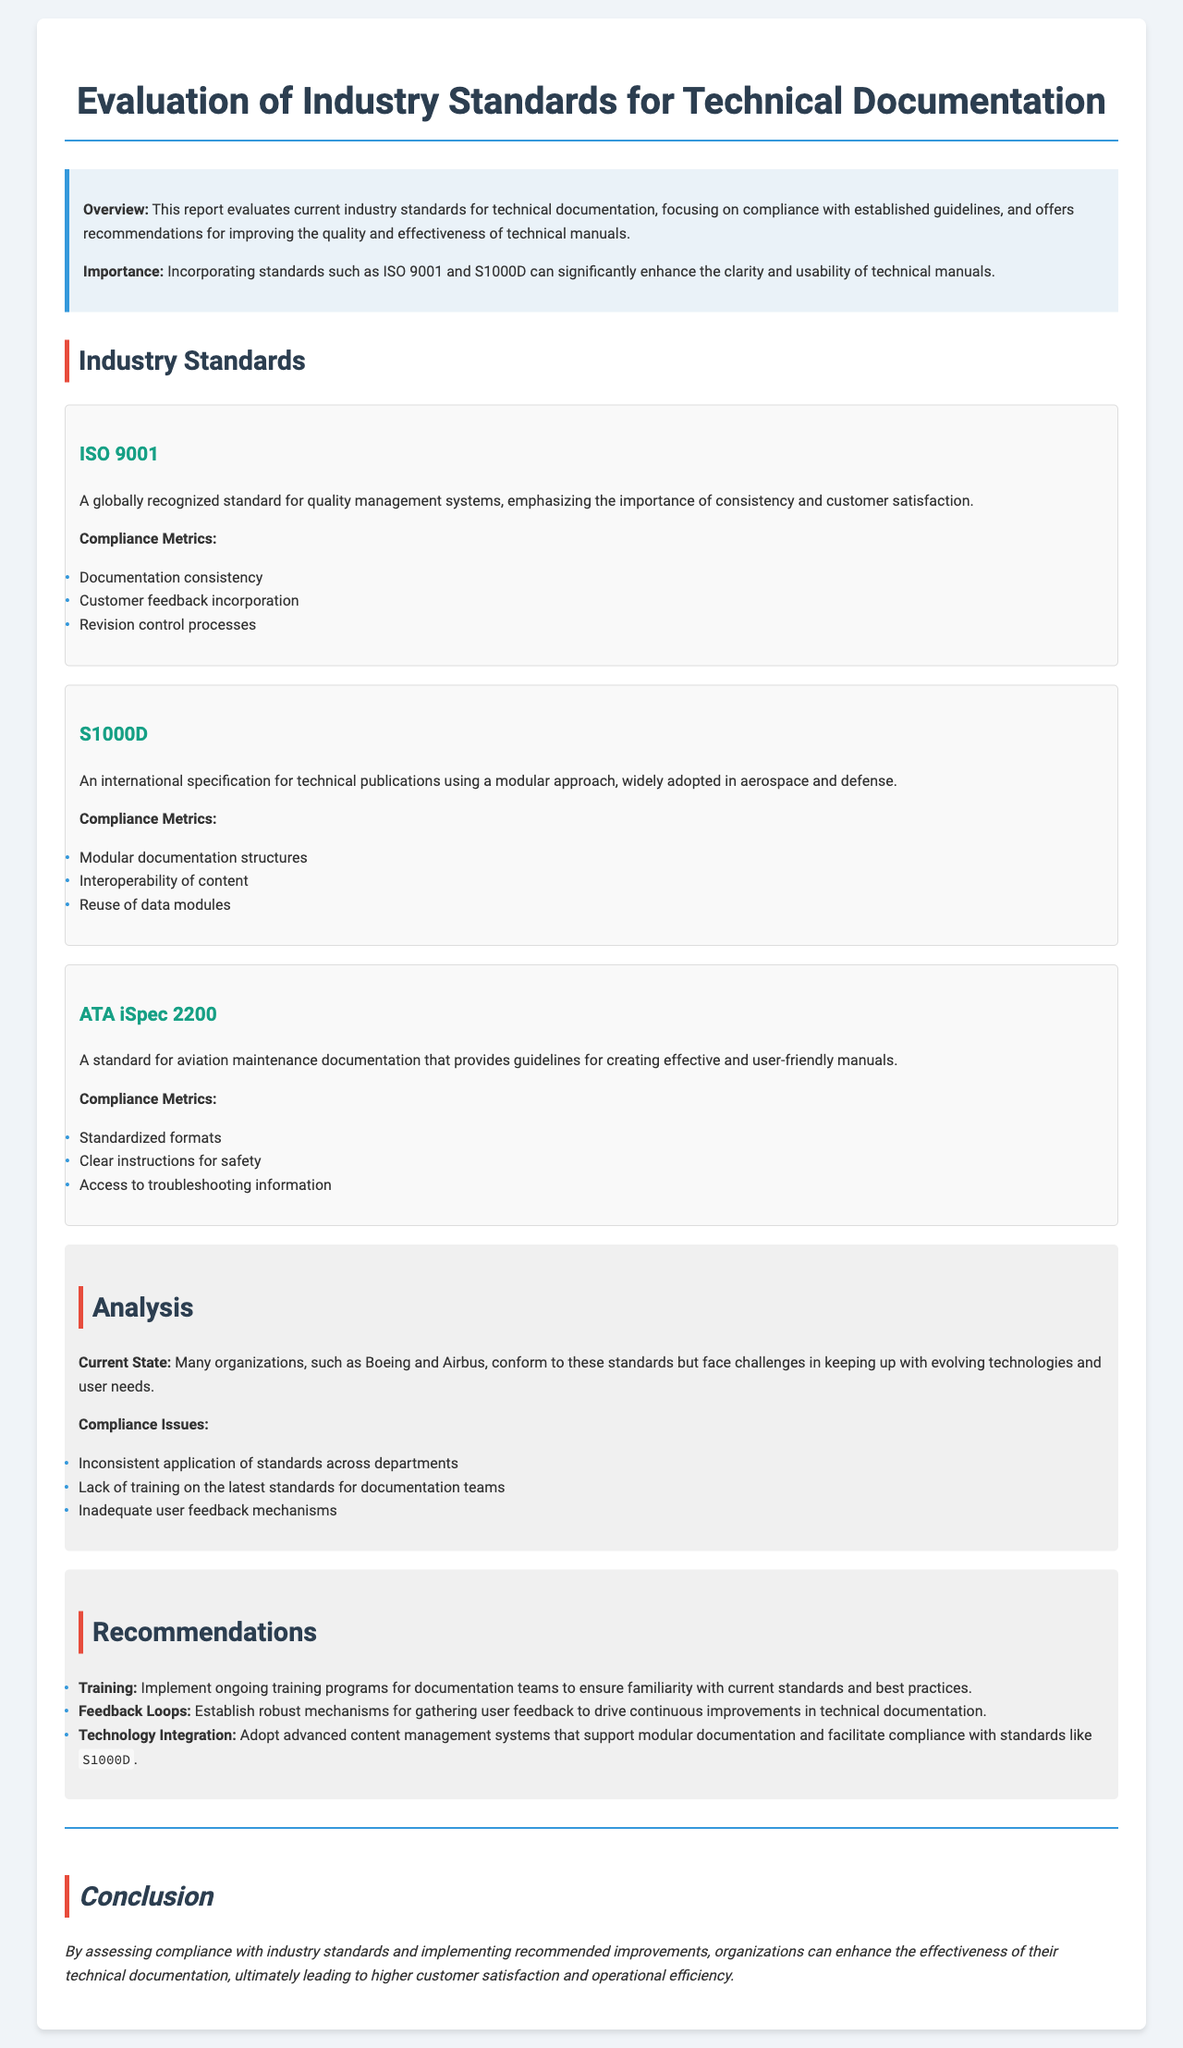What are the two main standards mentioned? The report discusses ISO 9001 and S1000D as primary industry standards for technical documentation.
Answer: ISO 9001, S1000D What is the focus of the report? The report focuses on evaluating compliance with industry standards for technical documentation and making recommendations for improvements.
Answer: Compliance and recommendations What metric is associated with ISO 9001? A compliance metric related to ISO 9001 includes consistency in documentation.
Answer: Documentation consistency What is a compliance issue identified in the analysis? The analysis section identifies the lack of training on the latest standards for documentation teams as a compliance issue.
Answer: Lack of training What is one recommendation provided in the report? The report recommends implementing ongoing training programs for documentation teams.
Answer: Ongoing training programs Which standard is associated with aviation maintenance documentation? The report states that ATA iSpec 2200 is a standard used for aviation maintenance documentation.
Answer: ATA iSpec 2200 What does S1000D emphasize in its compliance metrics? S1000D emphasizes the interoperability of content as one of its compliance metrics.
Answer: Interoperability of content What is the overall purpose of the recommendations section? The purpose of the recommendations section is to suggest improvements for compliance with technical documentation standards.
Answer: Suggest improvements What is a potential benefit of incorporating industry standards mentioned in the report? The report indicates that incorporating industry standards can enhance the clarity and usability of technical manuals.
Answer: Enhance clarity and usability 